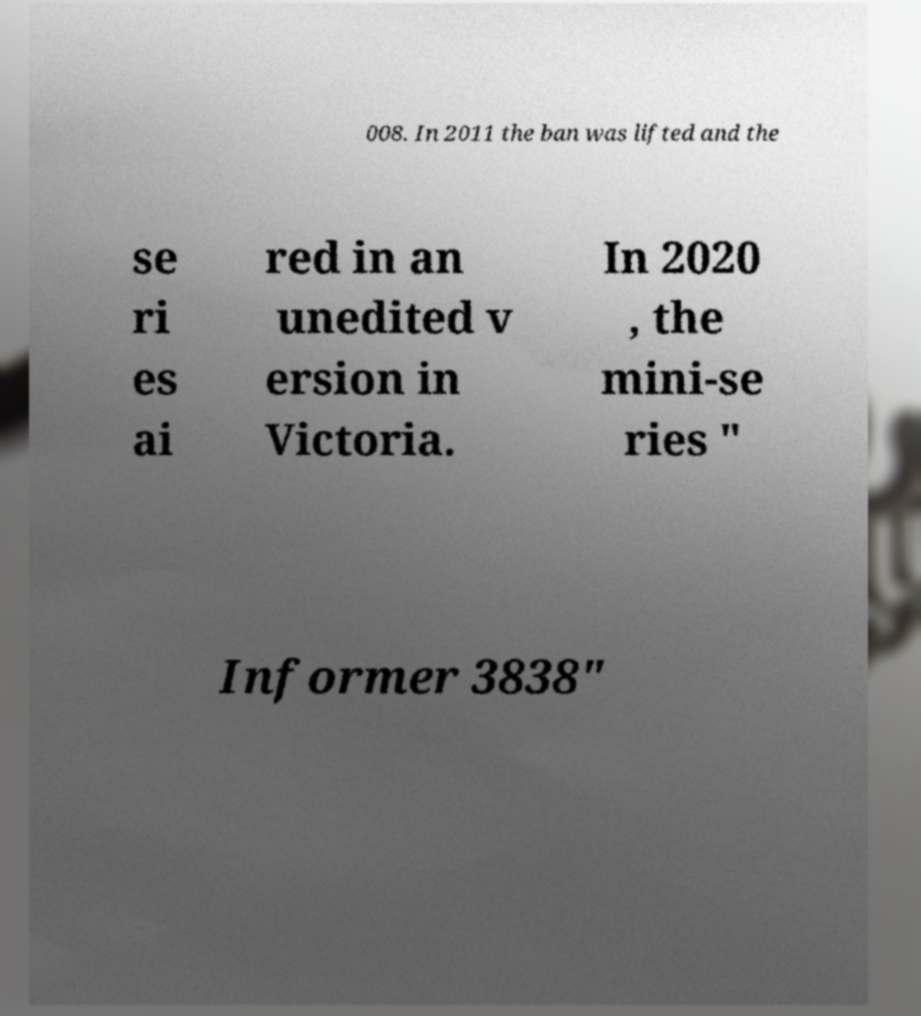Please read and relay the text visible in this image. What does it say? 008. In 2011 the ban was lifted and the se ri es ai red in an unedited v ersion in Victoria. In 2020 , the mini-se ries " Informer 3838" 